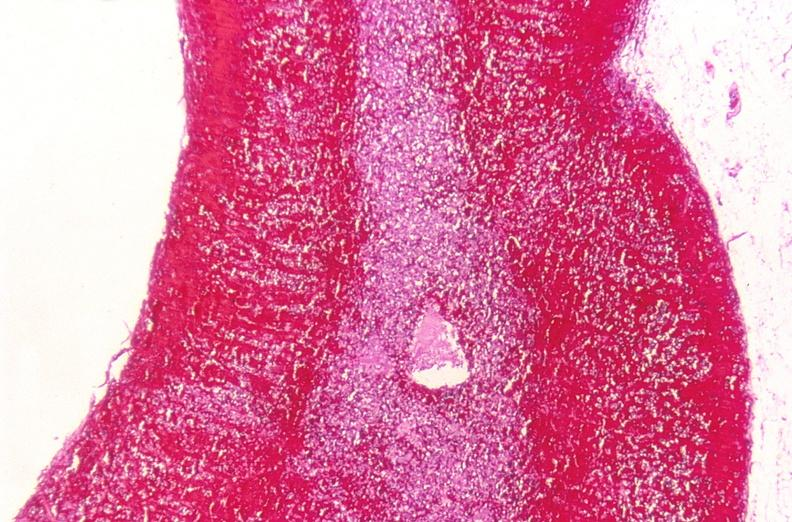what does this image show?
Answer the question using a single word or phrase. Adrenal gland 